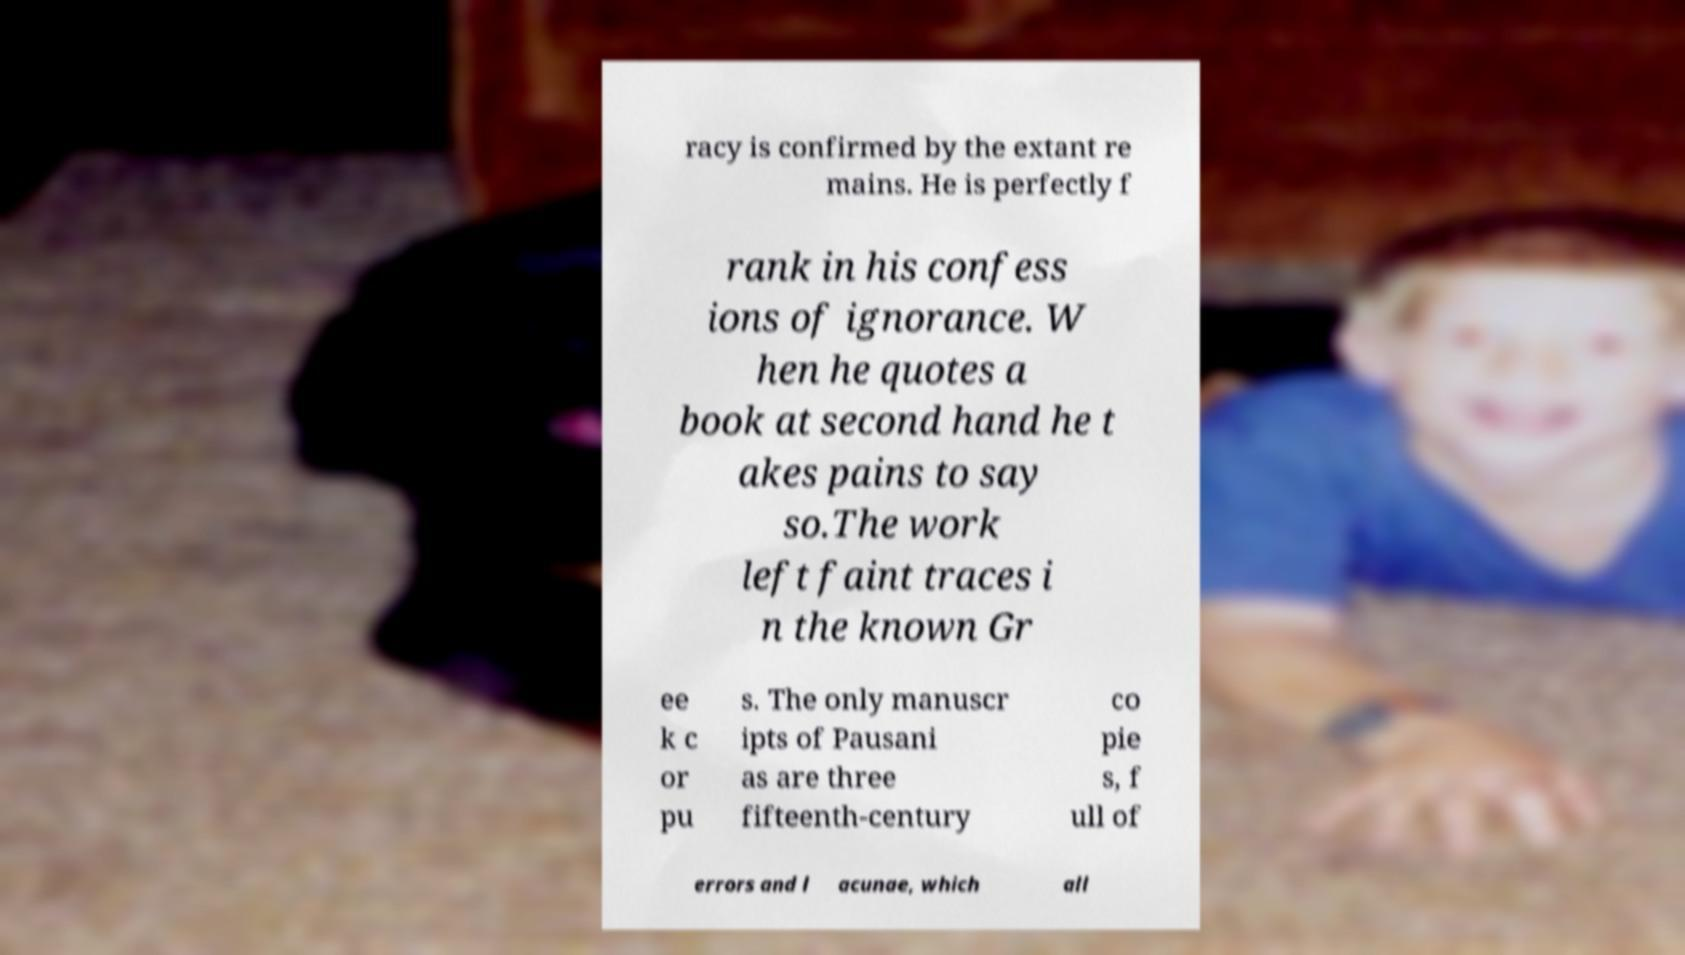Please identify and transcribe the text found in this image. racy is confirmed by the extant re mains. He is perfectly f rank in his confess ions of ignorance. W hen he quotes a book at second hand he t akes pains to say so.The work left faint traces i n the known Gr ee k c or pu s. The only manuscr ipts of Pausani as are three fifteenth-century co pie s, f ull of errors and l acunae, which all 